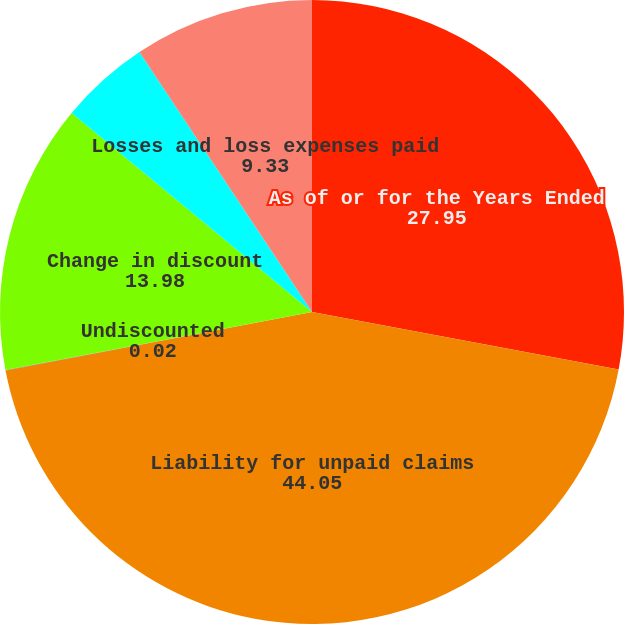Convert chart. <chart><loc_0><loc_0><loc_500><loc_500><pie_chart><fcel>As of or for the Years Ended<fcel>Liability for unpaid claims<fcel>Undiscounted<fcel>Change in discount<fcel>Losses and loss expenses<fcel>Losses and loss expenses paid<nl><fcel>27.95%<fcel>44.05%<fcel>0.02%<fcel>13.98%<fcel>4.67%<fcel>9.33%<nl></chart> 